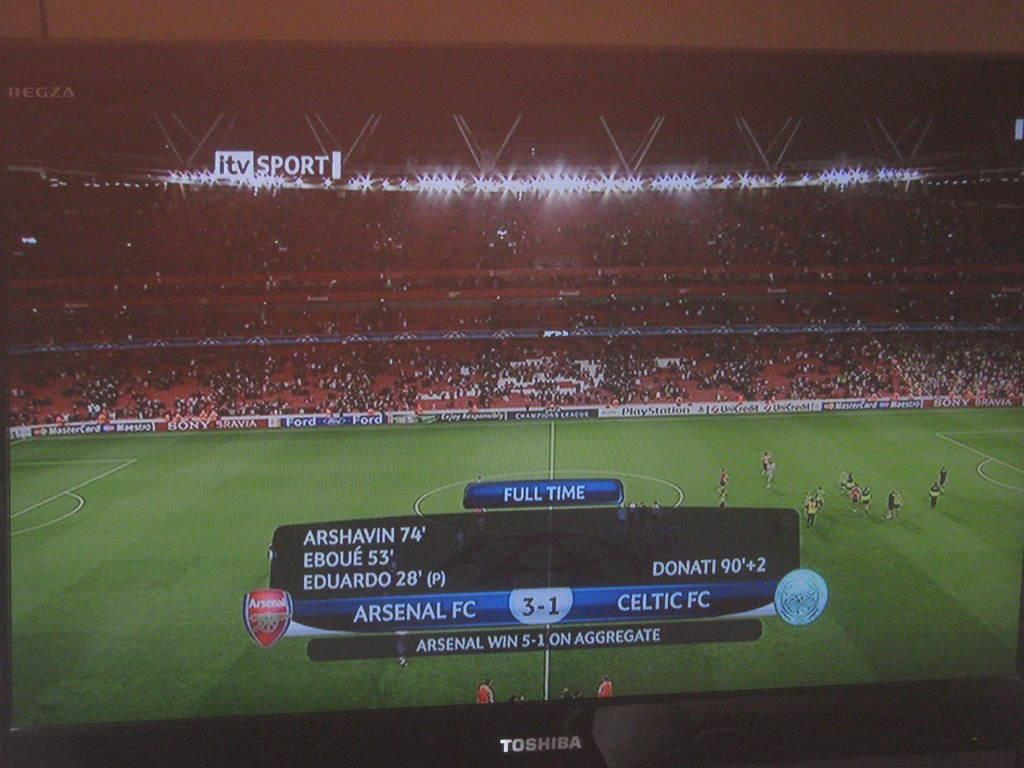<image>
Provide a brief description of the given image. A Toshiba television turned on to the itv sport channel. 